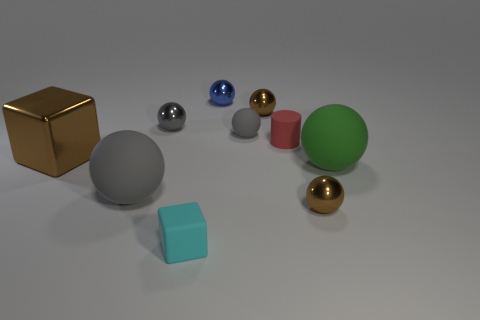How many other things are the same color as the small cube?
Give a very brief answer. 0. How many objects are small objects in front of the tiny blue shiny ball or tiny balls in front of the tiny gray rubber object?
Your response must be concise. 6. There is a matte thing that is to the right of the brown ball in front of the large brown thing; what size is it?
Offer a very short reply. Large. What size is the brown metal block?
Your answer should be very brief. Large. There is a small shiny object that is in front of the brown metal block; does it have the same color as the tiny ball that is on the left side of the cyan cube?
Provide a succinct answer. No. How many other things are there of the same material as the tiny red cylinder?
Offer a terse response. 4. Is there a cyan object?
Provide a succinct answer. Yes. Are the big sphere to the left of the gray metal object and the red thing made of the same material?
Your response must be concise. Yes. There is a green object that is the same shape as the small gray metallic object; what material is it?
Your answer should be very brief. Rubber. There is a tiny object that is the same color as the small matte ball; what material is it?
Offer a terse response. Metal. 